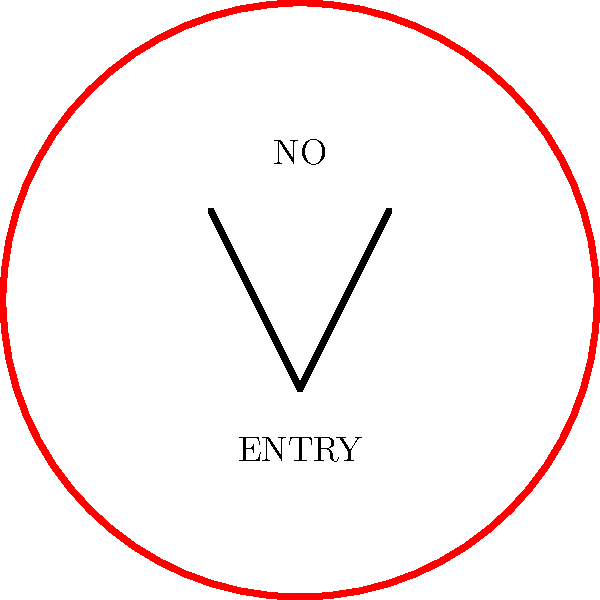What does this common street sign typically indicate in many urban areas? To interpret this street sign correctly, let's break it down step-by-step:

1. Shape: The sign is circular, which often indicates a prohibition or restriction.

2. Color: The sign has a red border, which is universally associated with warning, danger, or prohibition in traffic signs.

3. Symbol: Inside the circle, there's a horizontal black bar or arrow-like shape. This symbol typically represents a barrier or obstruction.

4. Text: The words "NO ENTRY" are clearly visible on the sign.

5. Cultural context: In many urban areas around the world, this combination of elements is used to indicate that vehicles are not allowed to enter a particular street or area from this direction.

Given these elements and the context of urban street signs, this sign is commonly used to prohibit vehicles from entering a street or area, often seen at the entrance of one-way streets when approached from the wrong direction.
Answer: No entry for vehicles 